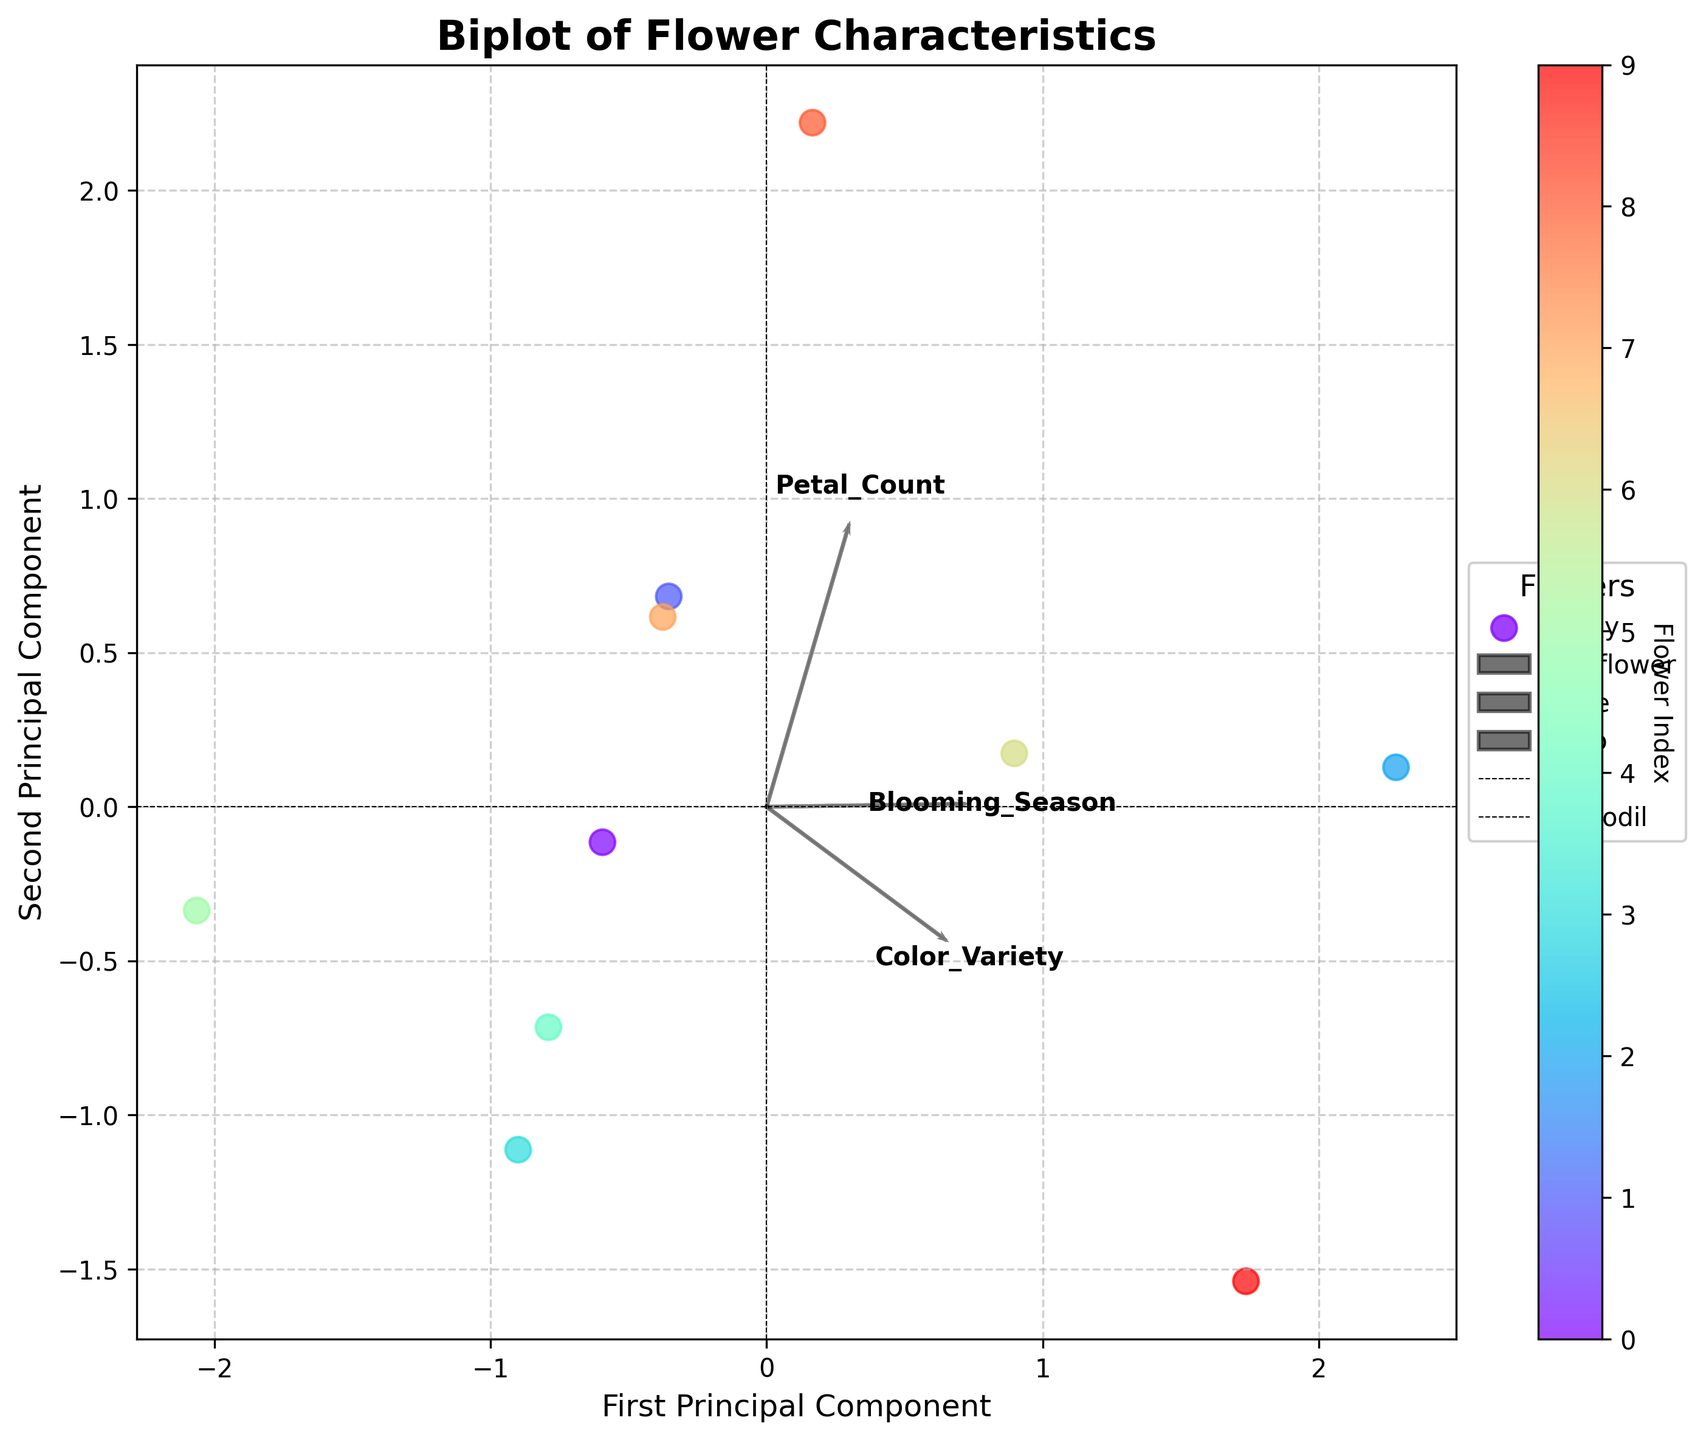What is the title of the biplot? The title of the biplot is usually found at the top center of the figure. In this case, it is displayed prominently in bold and larger font size.
Answer: Biplot of Flower Characteristics How many flowers are represented in the biplot? Each data point on the biplot represents a flower. We count the number of unique flower names associated with data points.
Answer: 10 Which flower has the highest number of petals according to the biplot? To determine the flower with the highest petal count, we look for the data point that corresponds to the maximum value along the direction of the "Petal_Count" feature vector.
Answer: Peony Which principal component explains more variance, the first or the second? Usually, the principal components are labeled along the axes. The component with the larger spread of data points explains more variance.
Answer: First Principal Component What are the axes labels of the biplot? The axes labels are displayed along the axes, indicating what each principal component represents.
Answer: First Principal Component and Second Principal Component Which two flowers seem to have the most similar properties based on the biplot? To find similar flowers, we look for data points that are close together.
Answer: Tulip and Lily Based on the biplot, which feature has the largest impact on the first principal component? The feature vector that aligns most closely with the direction of the first principal component indicates the largest impact.
Answer: Petal_Count What is the direction of the "Blooming_Season" feature in the biplot? The direction of the "Blooming_Season" feature is represented by the corresponding arrow. We look at the angle and orientation of this arrow.
Answer: Diagonally upwards and to the right Comparing "Rose" and "Chrysanthemum," which one shows a higher color variety? We examine the position of "Rose" and "Chrysanthemum" in relation to the "Color_Variety" vector. The flower closer to the arrow has a higher color variety.
Answer: Rose Which flower has a similar petal count but different blooming seasons compared to "Lily"? We identify flowers with data points aligned similarly along the "Petal_Count" vector but not along the "Blooming_Season" vector.
Answer: Daffodil 